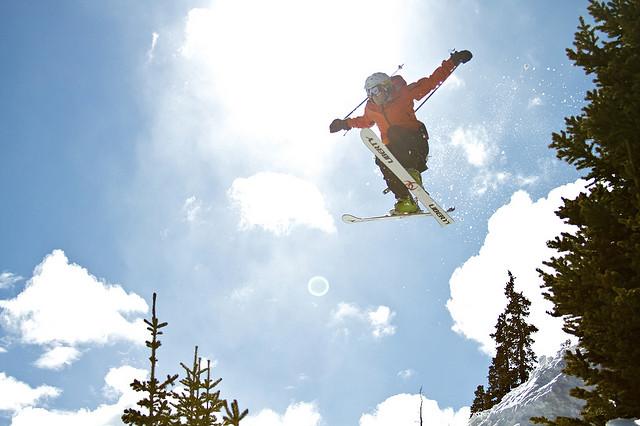Is it daytime?
Short answer required. Yes. What has wheels in the photo?
Quick response, please. Nothing. Might this man be drunk?
Give a very brief answer. No. Can you see the skiers face?
Short answer required. Yes. Is this man wearing a helmet?
Write a very short answer. Yes. Is there a lot of snow?
Keep it brief. Yes. Is the sun partly covered by clouds?
Give a very brief answer. Yes. Are there many clouds in the sky?
Be succinct. Yes. Is there a person in the sky?
Short answer required. Yes. 